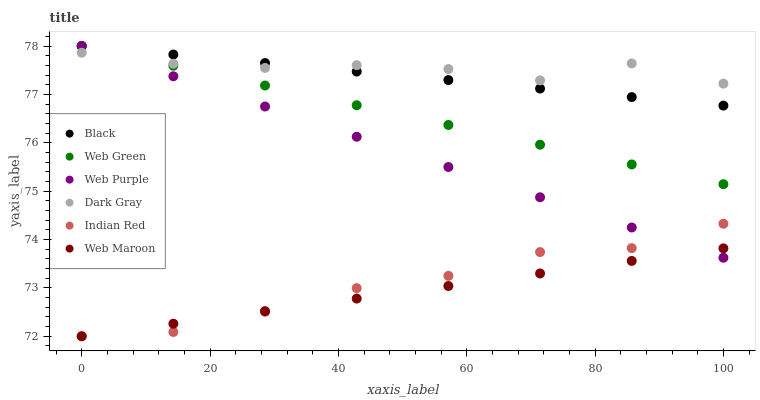Does Web Maroon have the minimum area under the curve?
Answer yes or no. Yes. Does Dark Gray have the maximum area under the curve?
Answer yes or no. Yes. Does Web Green have the minimum area under the curve?
Answer yes or no. No. Does Web Green have the maximum area under the curve?
Answer yes or no. No. Is Web Green the smoothest?
Answer yes or no. Yes. Is Dark Gray the roughest?
Answer yes or no. Yes. Is Dark Gray the smoothest?
Answer yes or no. No. Is Web Green the roughest?
Answer yes or no. No. Does Web Maroon have the lowest value?
Answer yes or no. Yes. Does Web Green have the lowest value?
Answer yes or no. No. Does Black have the highest value?
Answer yes or no. Yes. Does Dark Gray have the highest value?
Answer yes or no. No. Is Indian Red less than Web Green?
Answer yes or no. Yes. Is Black greater than Web Maroon?
Answer yes or no. Yes. Does Dark Gray intersect Web Green?
Answer yes or no. Yes. Is Dark Gray less than Web Green?
Answer yes or no. No. Is Dark Gray greater than Web Green?
Answer yes or no. No. Does Indian Red intersect Web Green?
Answer yes or no. No. 